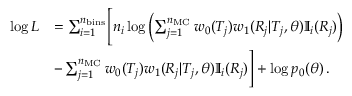<formula> <loc_0><loc_0><loc_500><loc_500>\begin{array} { r l } { \log L } & { = \sum _ { i = 1 } ^ { n _ { b i n s } } \left [ n _ { i } \log \left ( \sum _ { j = 1 } ^ { n _ { M C } } w _ { 0 } ( T _ { j } ) w _ { 1 } ( R _ { j } | T _ { j } , \theta ) \mathbb { I } _ { i } ( R _ { j } ) \right ) } \\ & { - \sum _ { j = 1 } ^ { n _ { M C } } w _ { 0 } ( T _ { j } ) w _ { 1 } ( R _ { j } | T _ { j } , \theta ) \mathbb { I } _ { i } ( R _ { j } ) \right ] + \log p _ { 0 } ( \theta ) \, . } \end{array}</formula> 